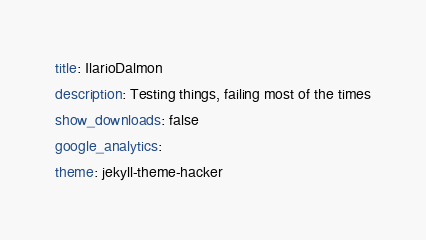<code> <loc_0><loc_0><loc_500><loc_500><_YAML_>title: IlarioDalmon
description: Testing things, failing most of the times
show_downloads: false
google_analytics:
theme: jekyll-theme-hacker</code> 